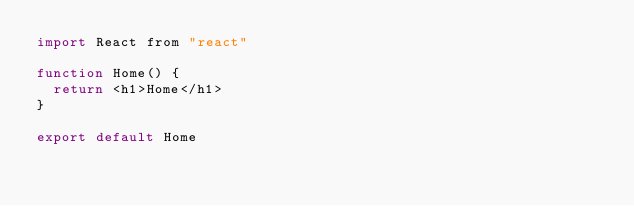Convert code to text. <code><loc_0><loc_0><loc_500><loc_500><_JavaScript_>import React from "react"

function Home() {
  return <h1>Home</h1>
}

export default Home
</code> 